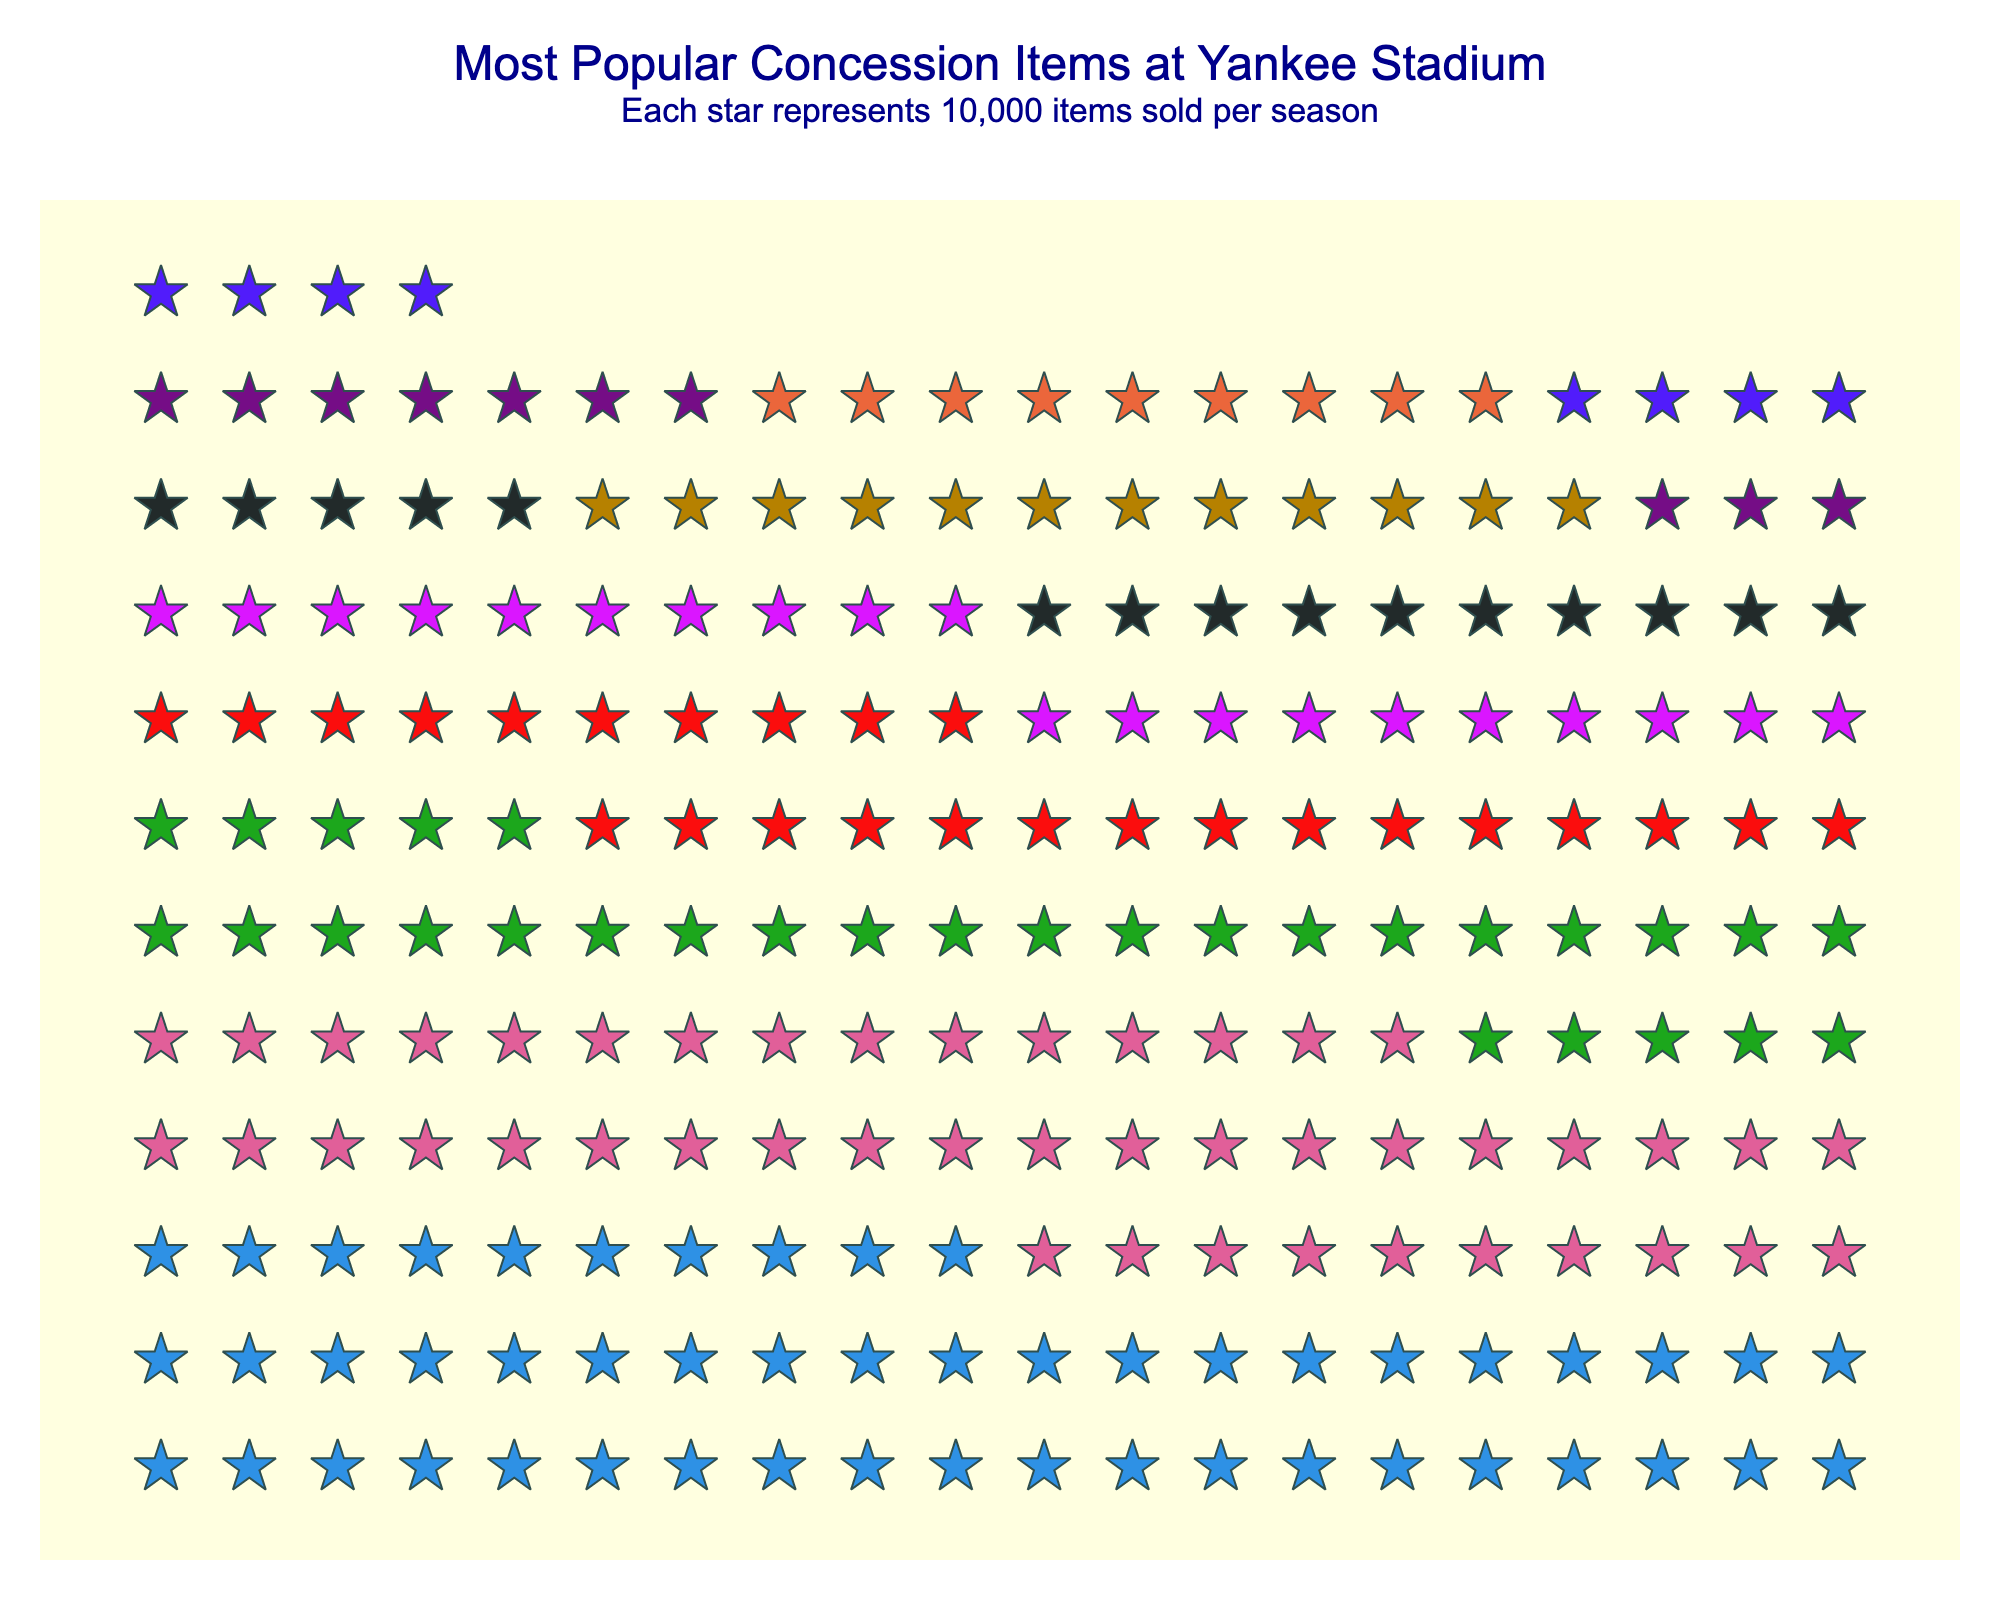How many stars represent Nachos on the plot? Each star represents 10,000 items sold. Nachos have 100,000 items sold, so 100,000 / 10,000 = 10 stars
Answer: 10 Which item is the most popular based on the plot? By looking at the number of stars, Hot Dogs have the most stars representing them, indicating the highest quantity sold
Answer: Hot Dogs What is the combined quantity sold for Peanuts and Soft Pretzels? Peanuts have 300,000 and Soft Pretzels have 250,000 items sold. Adding these together yields 300,000 + 250,000 = 550,000
Answer: 550,000 Which has a higher quantity sold, Ice Cream or Hamburgers? Comparing the number of stars, Hamburgers have 9 stars (90,000 items sold) and Ice Cream has 8 stars (80,000 items sold). Therefore, Hamburgers have a higher quantity sold
Answer: Hamburgers How much more popular is Cotton Candy compared to Ice Cream according to the plot? Cotton Candy has 150,000 items sold (15 stars), and Ice Cream has 80,000 items sold (8 stars). The difference is 150,000 - 80,000 = 70,000
Answer: 70,000 In terms of popularity, where does Yankees Caps rank among the items? Yankees Caps have 200,000 items sold, represented by 20 stars. This places them below Hot Dogs, Beer, Peanuts, and Soft Pretzels, ranking them 5th in popularity
Answer: 5th How many more items were sold for Beer compared to Nachos? Beer has 450,000 items sold (45 stars) and Nachos have 100,000 items sold (10 stars). The difference is 450,000 - 100,000 = 350,000
Answer: 350,000 Are Soft Pretzels or Yankees Caps sold in greater quantity according to the plot? Soft Pretzels have 250,000 items sold (25 stars) while Yankees Caps have 200,000 items sold (20 stars), indicating Soft Pretzels are sold in greater quantity
Answer: Soft Pretzels 